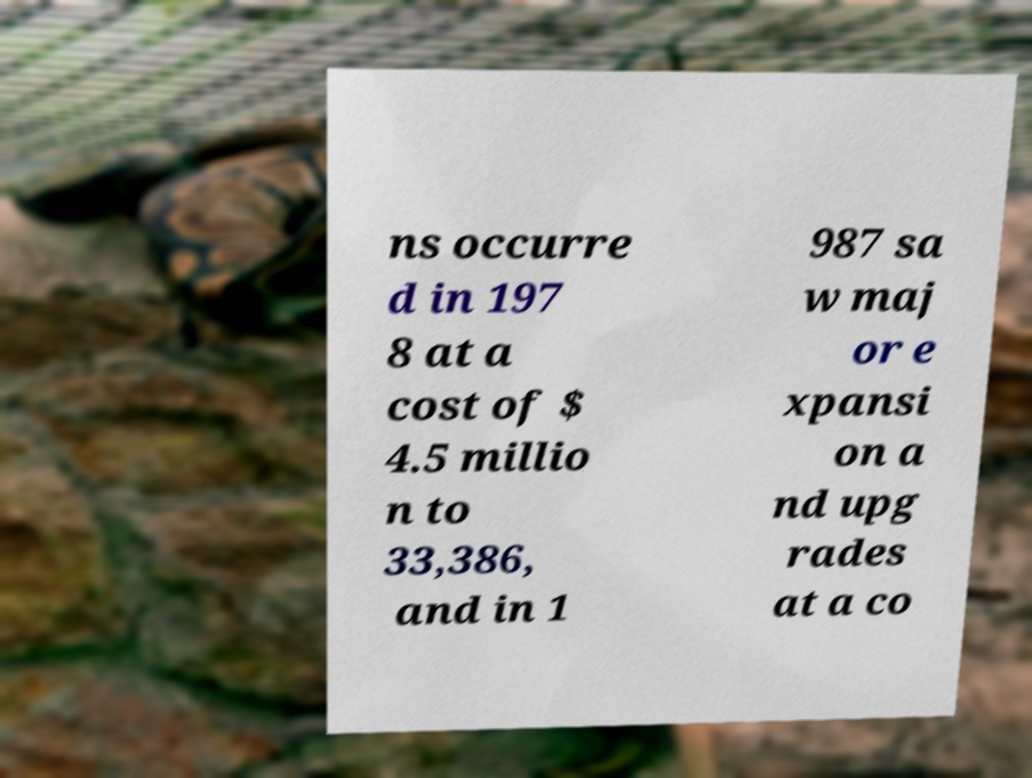For documentation purposes, I need the text within this image transcribed. Could you provide that? ns occurre d in 197 8 at a cost of $ 4.5 millio n to 33,386, and in 1 987 sa w maj or e xpansi on a nd upg rades at a co 